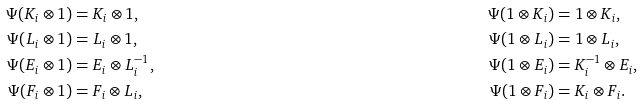<formula> <loc_0><loc_0><loc_500><loc_500>\Psi ( K _ { i } \otimes 1 ) & = K _ { i } \otimes 1 , & \Psi ( 1 \otimes K _ { i } ) & = 1 \otimes K _ { i } , \\ \Psi ( L _ { i } \otimes 1 ) & = L _ { i } \otimes 1 , & \Psi ( 1 \otimes L _ { i } ) & = 1 \otimes L _ { i } , \\ \Psi ( E _ { i } \otimes 1 ) & = E _ { i } \otimes L _ { i } ^ { - 1 } , & \Psi ( 1 \otimes E _ { i } ) & = K _ { i } ^ { - 1 } \otimes E _ { i } , \\ \Psi ( F _ { i } \otimes 1 ) & = F _ { i } \otimes L _ { i } , & \Psi ( 1 \otimes F _ { i } ) & = K _ { i } \otimes F _ { i } .</formula> 